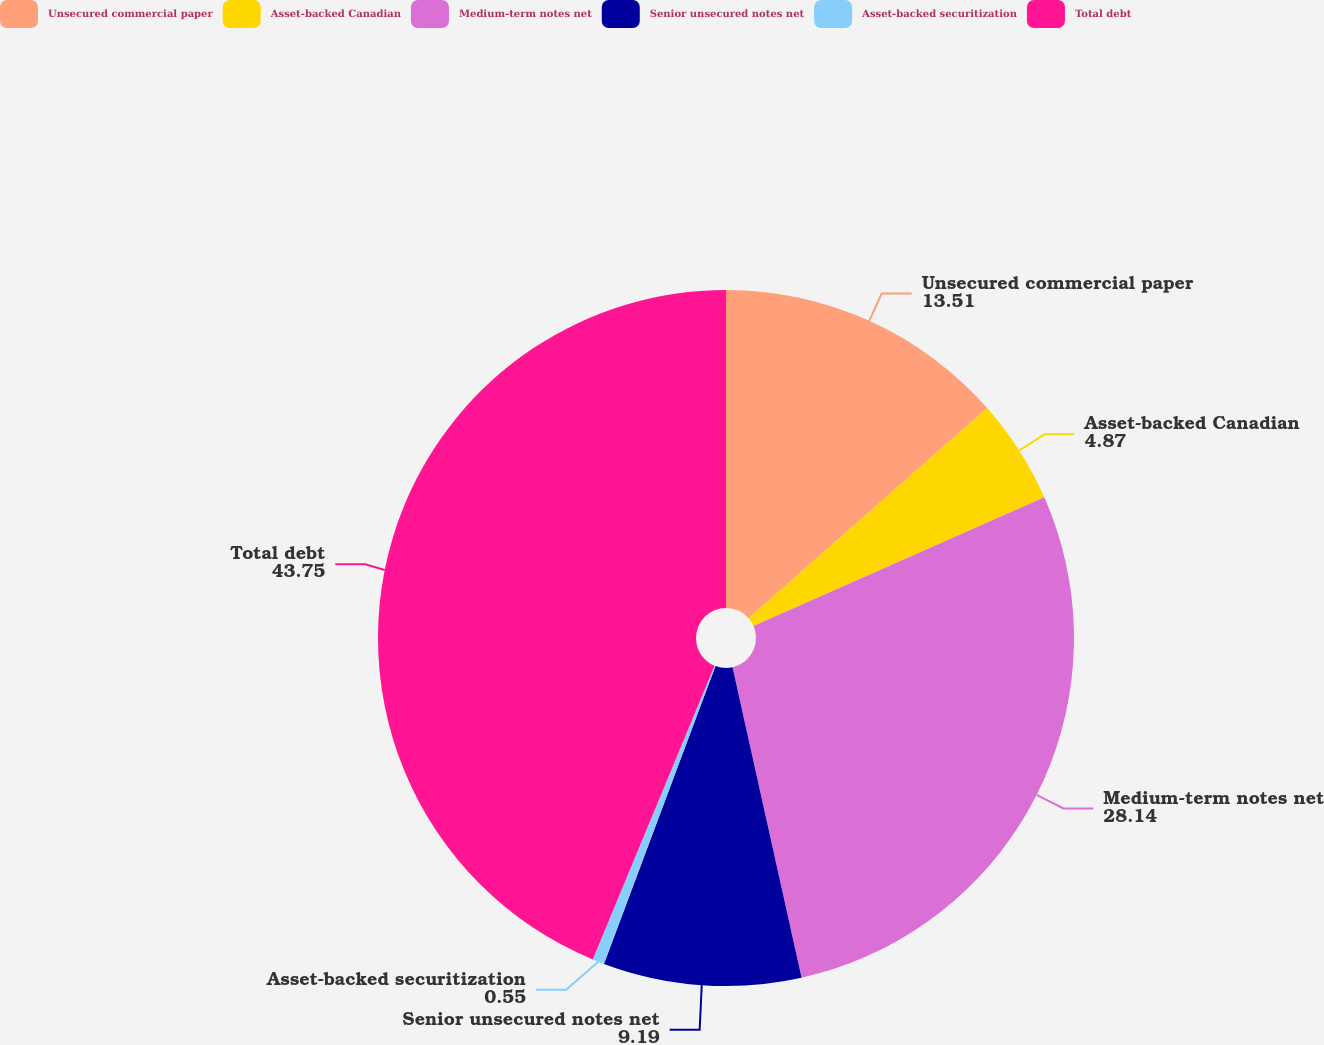<chart> <loc_0><loc_0><loc_500><loc_500><pie_chart><fcel>Unsecured commercial paper<fcel>Asset-backed Canadian<fcel>Medium-term notes net<fcel>Senior unsecured notes net<fcel>Asset-backed securitization<fcel>Total debt<nl><fcel>13.51%<fcel>4.87%<fcel>28.14%<fcel>9.19%<fcel>0.55%<fcel>43.75%<nl></chart> 